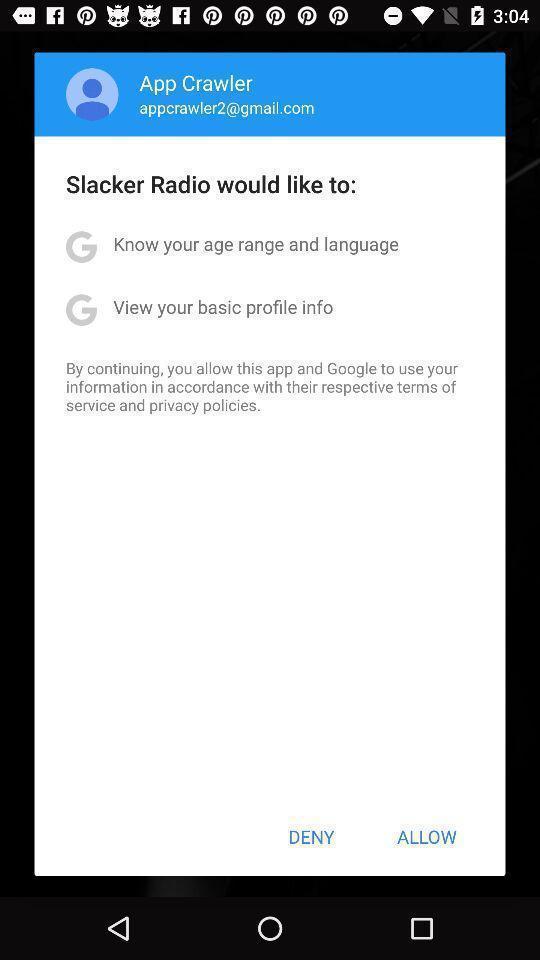Tell me what you see in this picture. Pop-up asking permissions to access the profile details. 